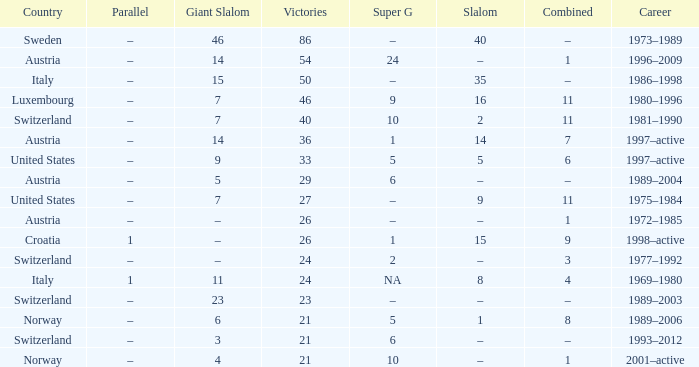Can you give me this table as a dict? {'header': ['Country', 'Parallel', 'Giant Slalom', 'Victories', 'Super G', 'Slalom', 'Combined', 'Career'], 'rows': [['Sweden', '–', '46', '86', '–', '40', '–', '1973–1989'], ['Austria', '–', '14', '54', '24', '–', '1', '1996–2009'], ['Italy', '–', '15', '50', '–', '35', '–', '1986–1998'], ['Luxembourg', '–', '7', '46', '9', '16', '11', '1980–1996'], ['Switzerland', '–', '7', '40', '10', '2', '11', '1981–1990'], ['Austria', '–', '14', '36', '1', '14', '7', '1997–active'], ['United States', '–', '9', '33', '5', '5', '6', '1997–active'], ['Austria', '–', '5', '29', '6', '–', '–', '1989–2004'], ['United States', '–', '7', '27', '–', '9', '11', '1975–1984'], ['Austria', '–', '–', '26', '–', '–', '1', '1972–1985'], ['Croatia', '1', '–', '26', '1', '15', '9', '1998–active'], ['Switzerland', '–', '–', '24', '2', '–', '3', '1977–1992'], ['Italy', '1', '11', '24', 'NA', '8', '4', '1969–1980'], ['Switzerland', '–', '23', '23', '–', '–', '–', '1989–2003'], ['Norway', '–', '6', '21', '5', '1', '8', '1989–2006'], ['Switzerland', '–', '3', '21', '6', '–', '–', '1993–2012'], ['Norway', '–', '4', '21', '10', '–', '1', '2001–active']]} What Career has a Super G of 5, and a Combined of 6? 1997–active. 